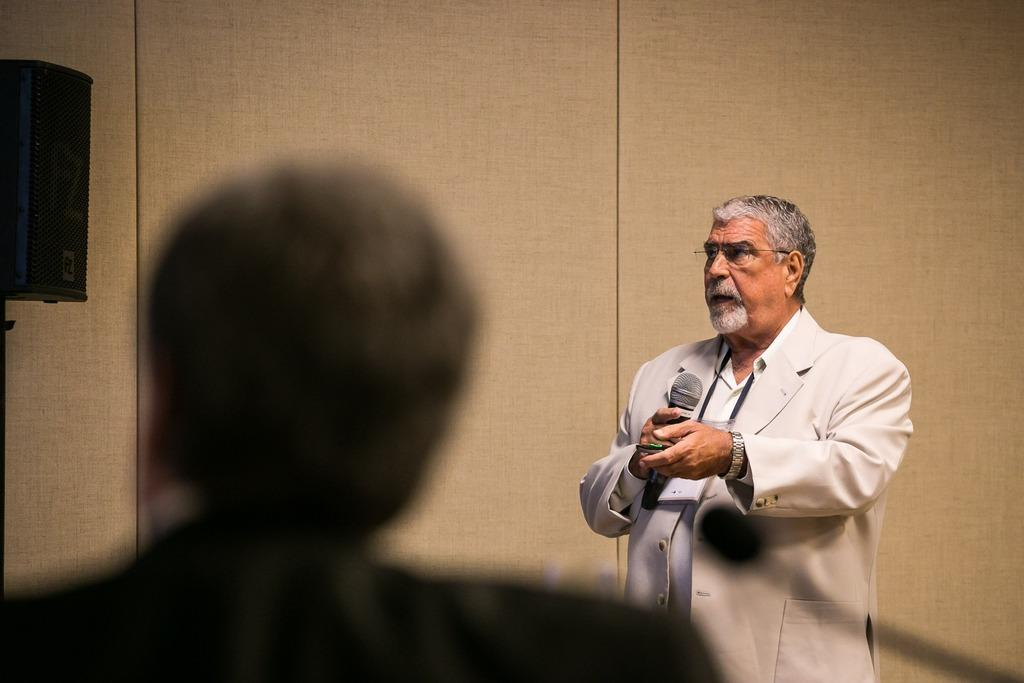What is the main subject of the image? The main subject of the image is a man. What is the man doing in the image? The man is standing and talking on a microphone. Can you describe the man's appearance? The man is wearing spectacles. What can be seen in the background of the image? There is a wall in the background of the image. Where is the cactus located in the image? There is no cactus present in the image. What type of pump is being used by the man in the image? The man is not using a pump in the image; he is talking on a microphone. 